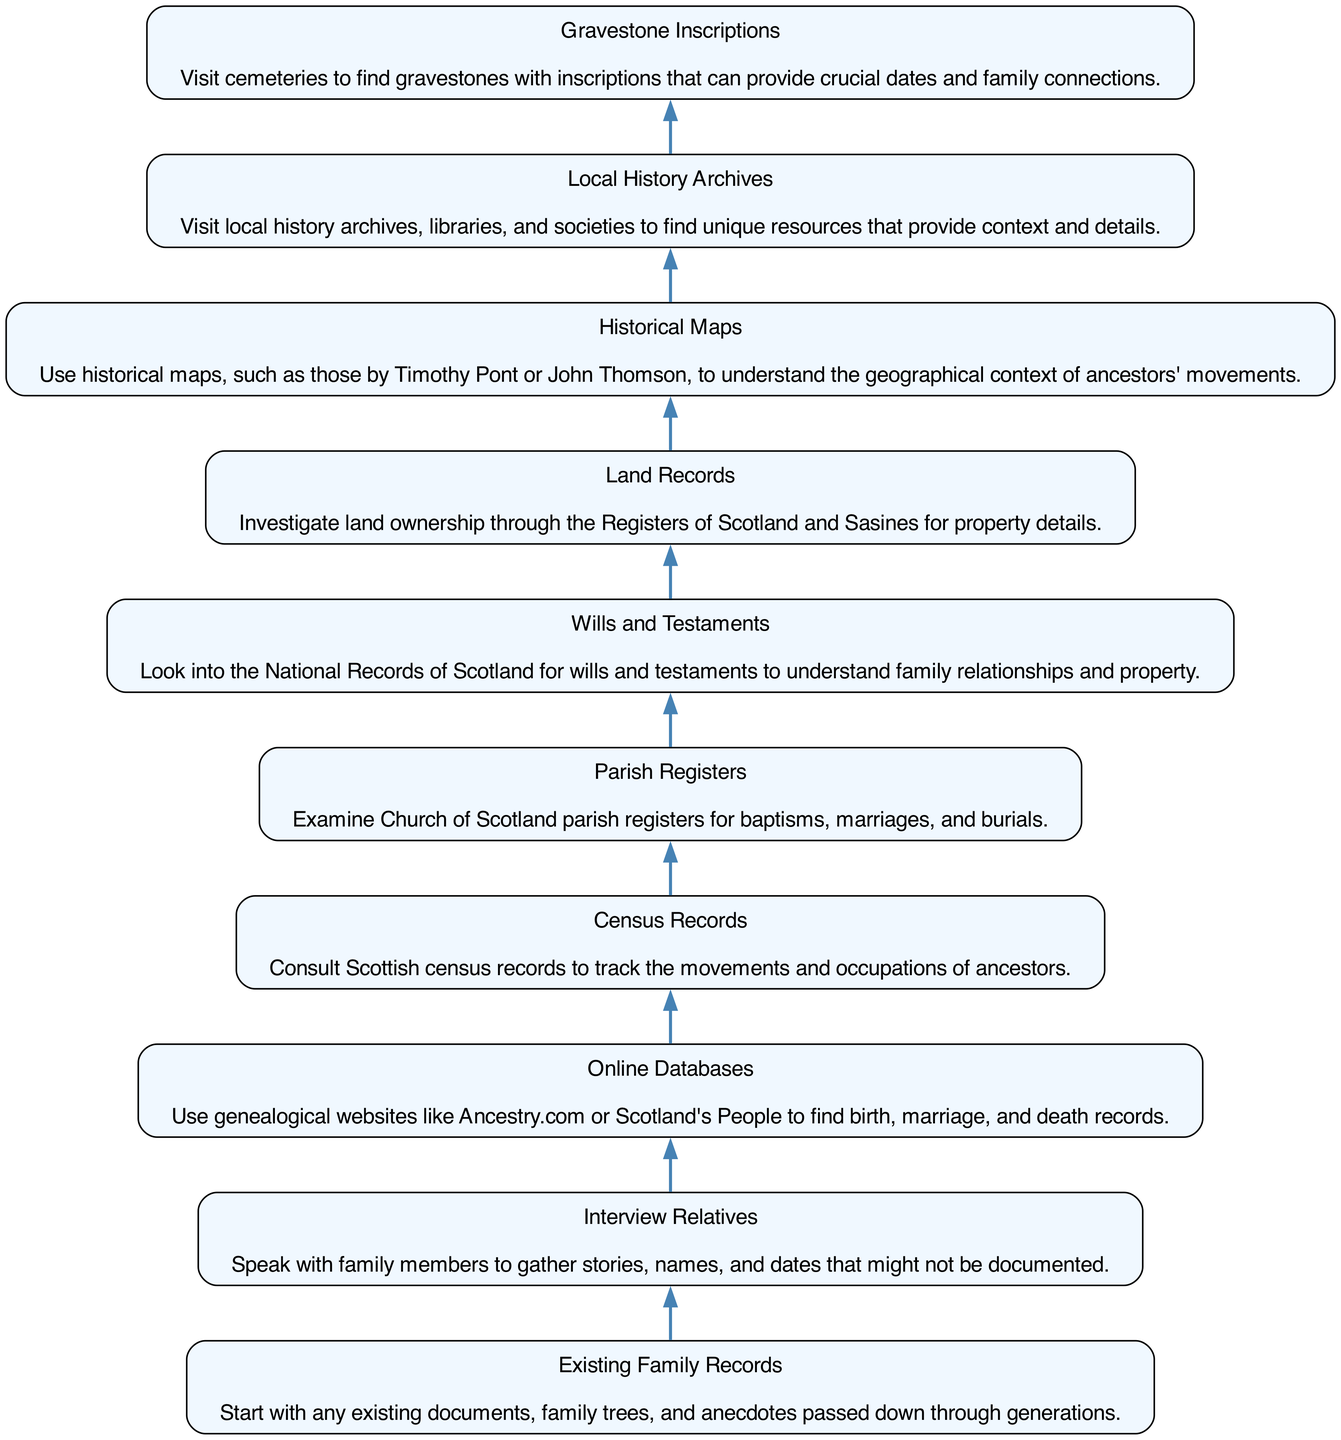What is the first step in the genealogical research journey? The first step in the journey, as depicted in the diagram, is "Existing Family Records." This is the starting point from which all genealogical research begins.
Answer: Existing Family Records How many steps are included in the diagram? The diagram consists of 10 steps in total, each representing a distinct phase of the genealogical research journey.
Answer: 10 What follows "Interview Relatives" in the flowchart? After the "Interview Relatives" step, the flowchart indicates that you should proceed to "Online Databases." This shows the sequence of steps in the journey.
Answer: Online Databases Which step involves looking into property ownership details? The step that involves investigating land ownership through the Registers of Scotland and Sasines is titled "Land Records." This explicitly focuses on property details within genealogical research.
Answer: Land Records What are the last two steps in the diagram? The last two steps, listed in order from the bottom, are "Gravestone Inscriptions" and "Local History Archives." These indicate the final stages of the genealogical journey.
Answer: Gravestone Inscriptions and Local History Archives In what step would you consult Scottish census records? The step dedicated to consulting census records is simply labeled "Census Records.” It is emphasized as a significant resource in tracking ancestors' movements across generations.
Answer: Census Records Which node provides insight into family relationships and property? The node labeled "Wills and Testaments" pertains to understanding family relationships and property, as it directs you to the National Records of Scotland for insights.
Answer: Wills and Testaments What is the main purpose of examining parish registers? The main purpose of examining "Parish Registers" is to look for vital records such as baptisms, marriages, and burials, which are key to constructing family histories.
Answer: Vital records 